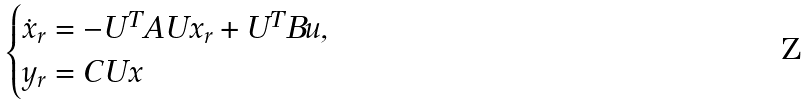Convert formula to latex. <formula><loc_0><loc_0><loc_500><loc_500>\begin{cases} \dot { x } _ { r } = - U ^ { T } A U x _ { r } + U ^ { T } B u , \\ y _ { r } = C U x \end{cases}</formula> 